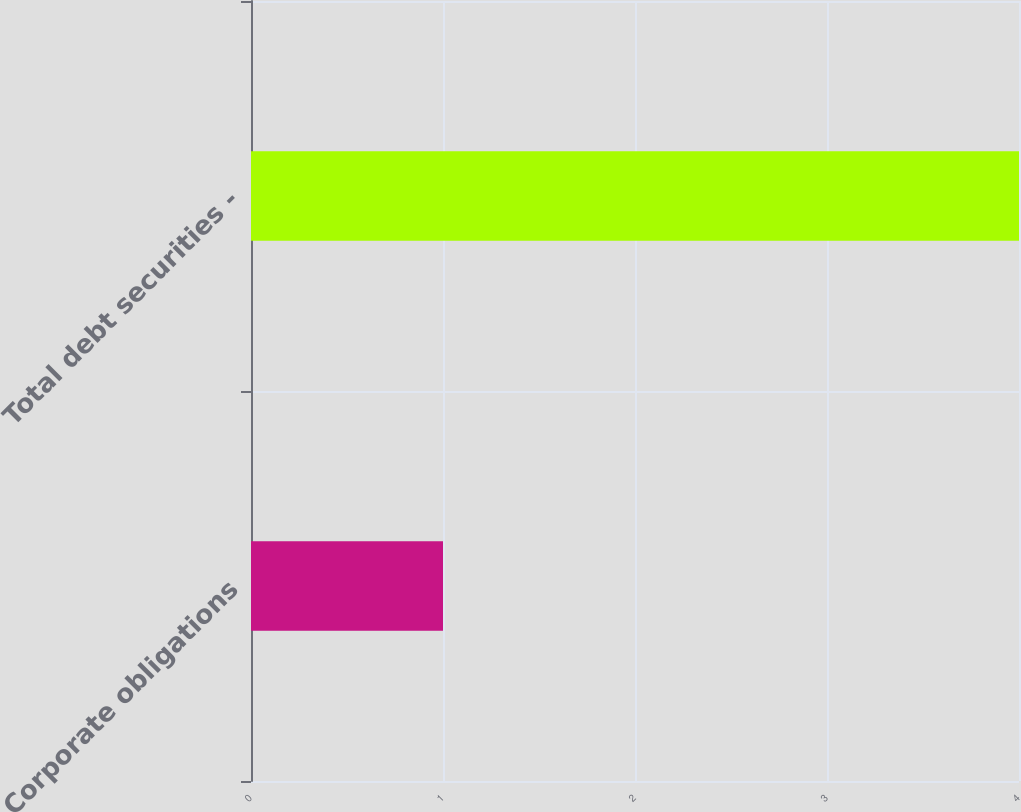Convert chart to OTSL. <chart><loc_0><loc_0><loc_500><loc_500><bar_chart><fcel>Corporate obligations<fcel>Total debt securities -<nl><fcel>1<fcel>4<nl></chart> 